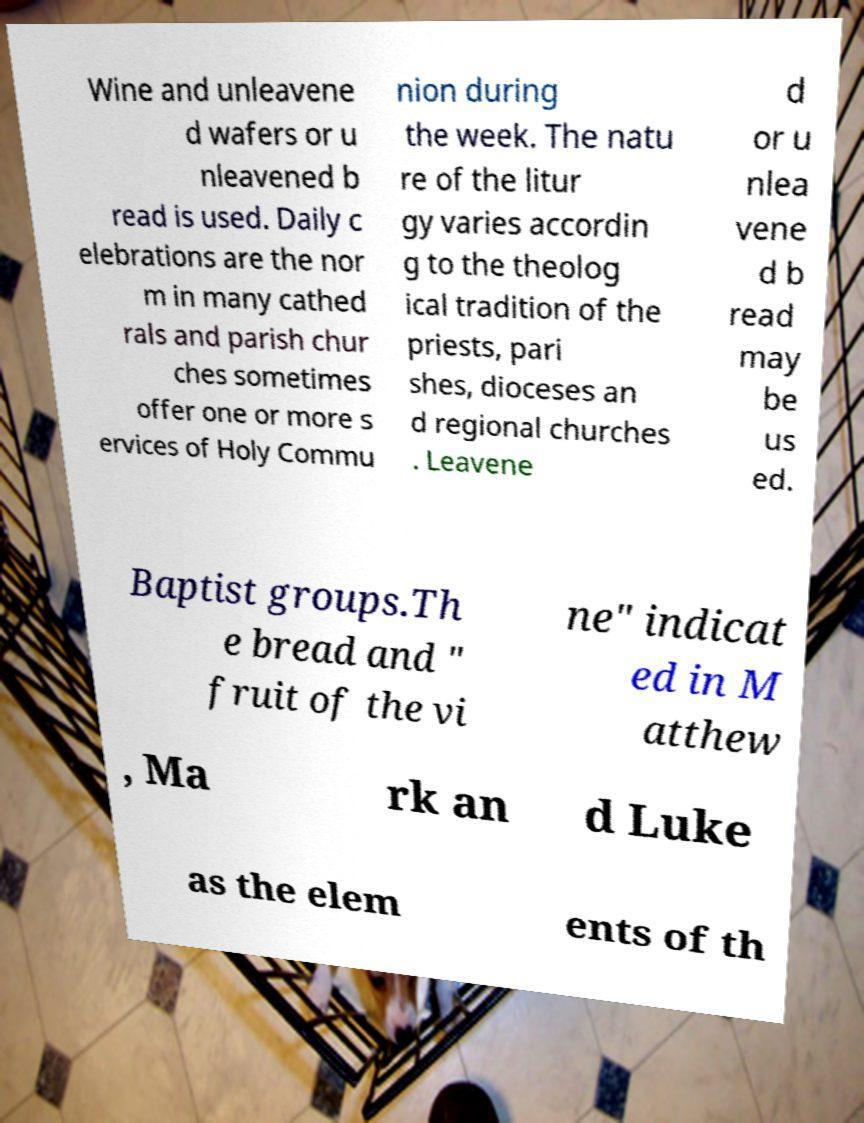I need the written content from this picture converted into text. Can you do that? Wine and unleavene d wafers or u nleavened b read is used. Daily c elebrations are the nor m in many cathed rals and parish chur ches sometimes offer one or more s ervices of Holy Commu nion during the week. The natu re of the litur gy varies accordin g to the theolog ical tradition of the priests, pari shes, dioceses an d regional churches . Leavene d or u nlea vene d b read may be us ed. Baptist groups.Th e bread and " fruit of the vi ne" indicat ed in M atthew , Ma rk an d Luke as the elem ents of th 